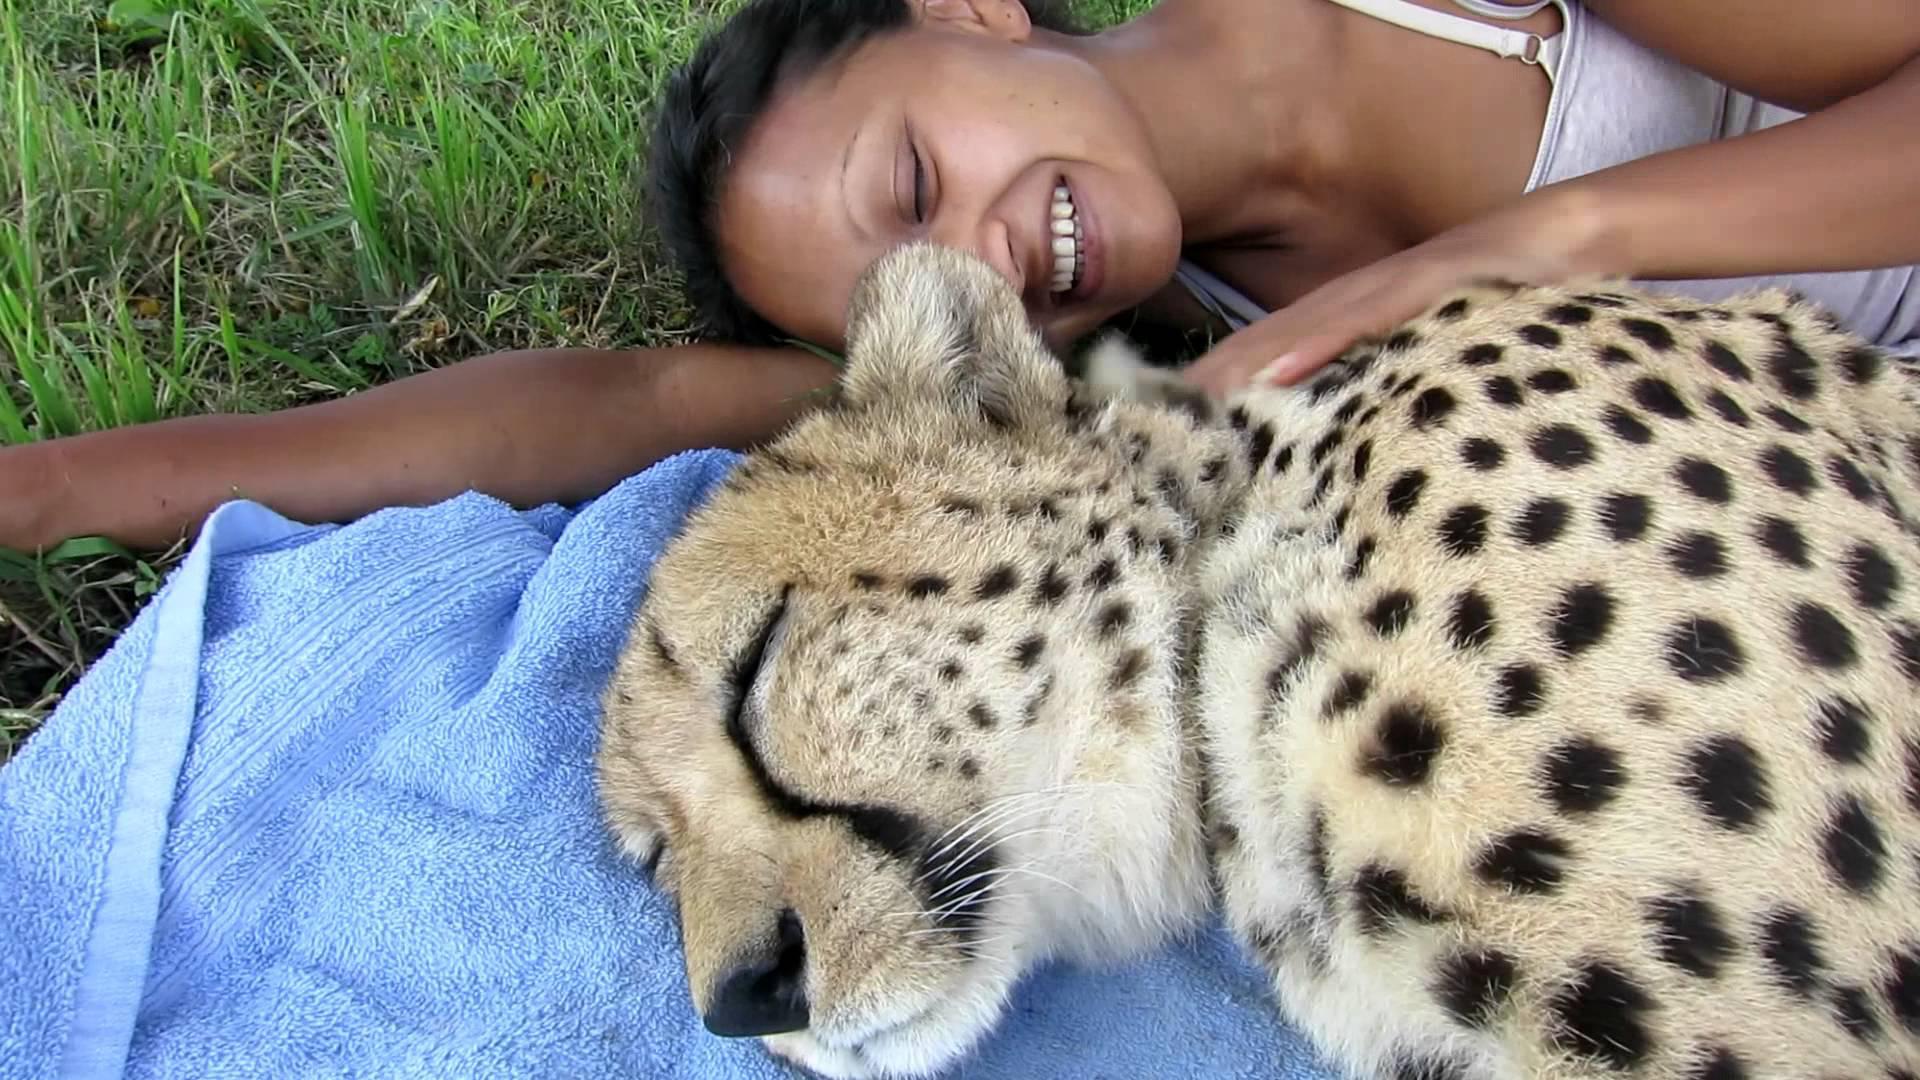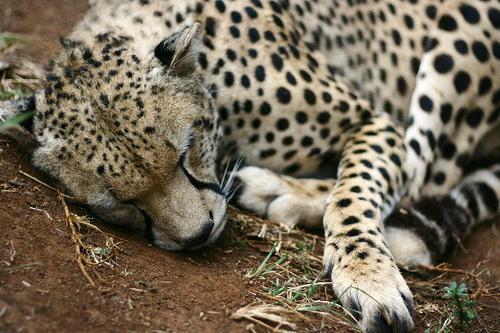The first image is the image on the left, the second image is the image on the right. Analyze the images presented: Is the assertion "There is a cheetah sleeping in a tree" valid? Answer yes or no. No. The first image is the image on the left, the second image is the image on the right. Considering the images on both sides, is "There is one cheetah sleeping in a tree." valid? Answer yes or no. No. 